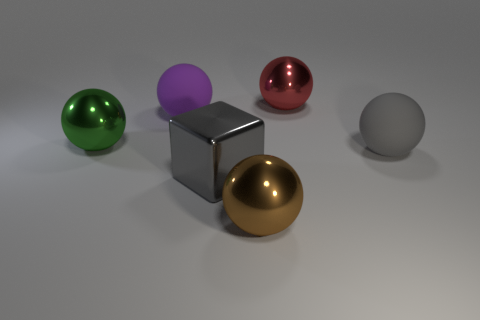Subtract all purple balls. How many balls are left? 4 Subtract all gray balls. How many balls are left? 4 Subtract all cyan balls. Subtract all purple cubes. How many balls are left? 5 Add 2 blue balls. How many objects exist? 8 Subtract all cubes. How many objects are left? 5 Add 5 large gray matte balls. How many large gray matte balls exist? 6 Subtract 0 green blocks. How many objects are left? 6 Subtract all brown metallic objects. Subtract all red spheres. How many objects are left? 4 Add 2 big green spheres. How many big green spheres are left? 3 